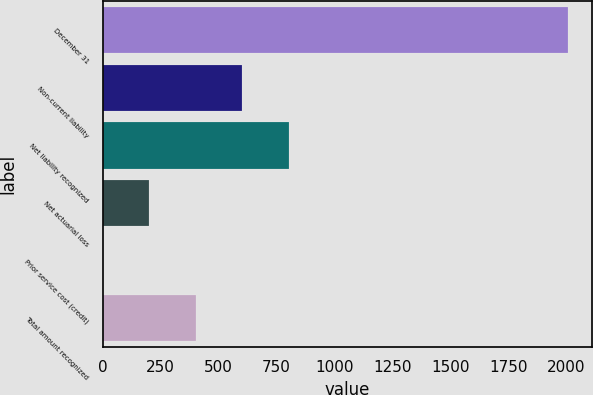Convert chart to OTSL. <chart><loc_0><loc_0><loc_500><loc_500><bar_chart><fcel>December 31<fcel>Non-current liability<fcel>Net liability recognized<fcel>Net actuarial loss<fcel>Prior service cost (credit)<fcel>Total amount recognized<nl><fcel>2009<fcel>603.05<fcel>803.9<fcel>201.35<fcel>0.5<fcel>402.2<nl></chart> 